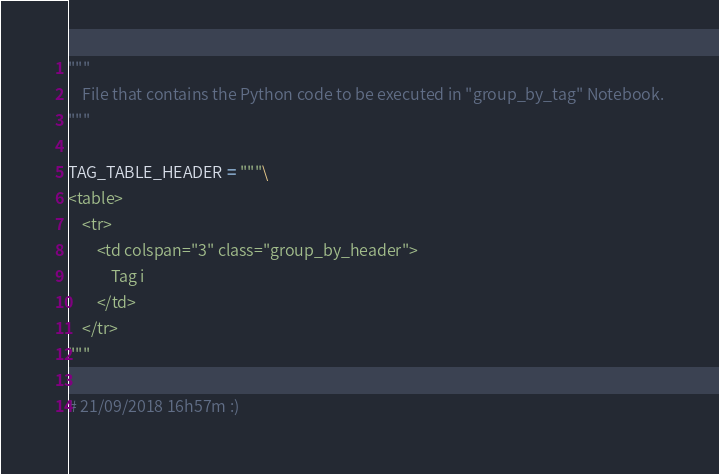<code> <loc_0><loc_0><loc_500><loc_500><_Python_>"""
    File that contains the Python code to be executed in "group_by_tag" Notebook.
"""

TAG_TABLE_HEADER = """\
<table>
    <tr>
        <td colspan="3" class="group_by_header">
            Tag i
        </td>
    </tr>
"""

# 21/09/2018 16h57m :)</code> 